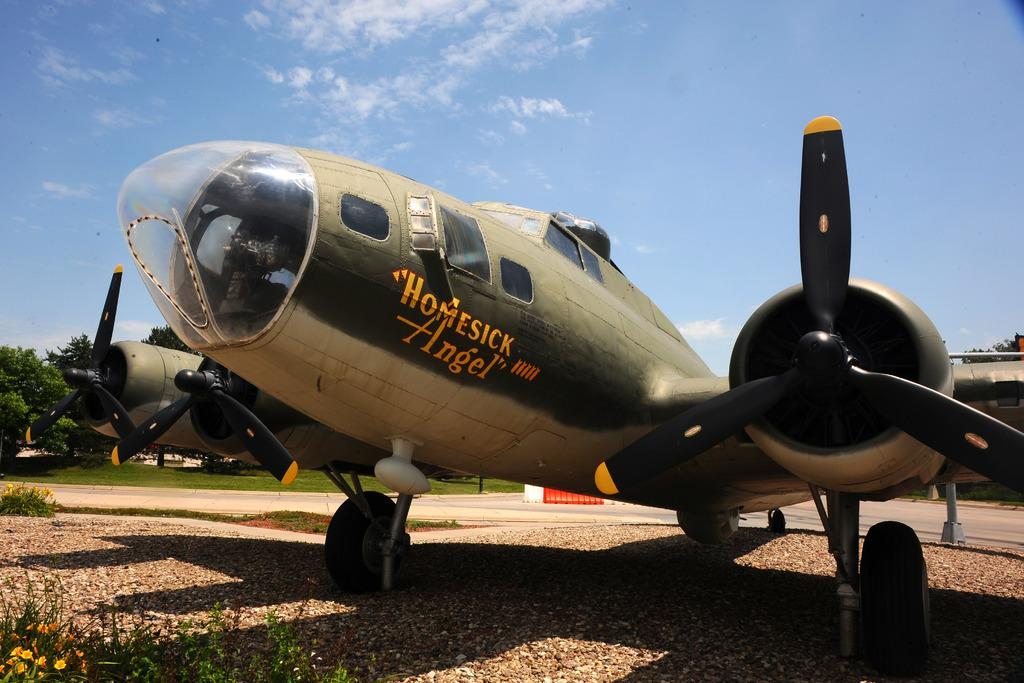What is the main subject of the image? The main subject of the image is an aircraft. Can you describe the colors of the aircraft? The aircraft is green and white in color. What can be seen on the left side of the image? There are trees on the left side of the image. What is the color of the trees? The trees are green in color. What is visible at the top of the image? The sky is visible at the top of the image. Can you describe the colors of the sky? The sky is white and blue in color. Who is the manager of the pie in the image? There is no pie present in the image, so there is no manager for a pie. 